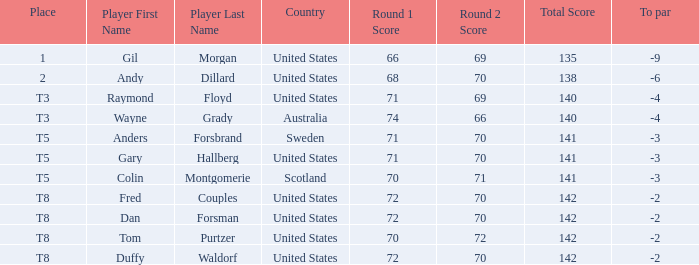What exactly is the t8 place player? Fred Couples, Dan Forsman, Tom Purtzer, Duffy Waldorf. 